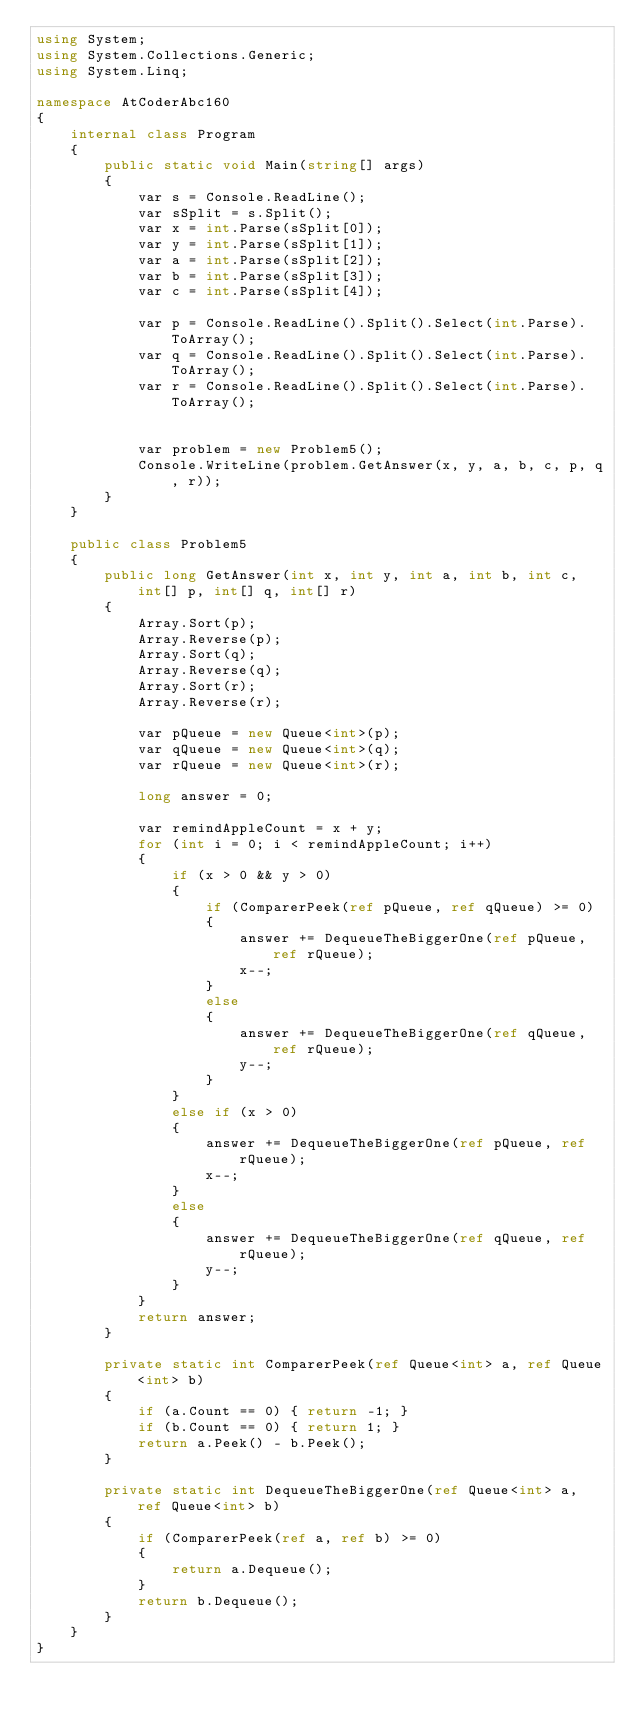<code> <loc_0><loc_0><loc_500><loc_500><_C#_>using System;
using System.Collections.Generic;
using System.Linq;

namespace AtCoderAbc160
{
    internal class Program
    {
        public static void Main(string[] args)
        {
            var s = Console.ReadLine();
            var sSplit = s.Split();
            var x = int.Parse(sSplit[0]);
            var y = int.Parse(sSplit[1]);
            var a = int.Parse(sSplit[2]);
            var b = int.Parse(sSplit[3]);
            var c = int.Parse(sSplit[4]);

            var p = Console.ReadLine().Split().Select(int.Parse).ToArray();
            var q = Console.ReadLine().Split().Select(int.Parse).ToArray();
            var r = Console.ReadLine().Split().Select(int.Parse).ToArray();


            var problem = new Problem5();
            Console.WriteLine(problem.GetAnswer(x, y, a, b, c, p, q, r));
        }
    }

    public class Problem5
    {
        public long GetAnswer(int x, int y, int a, int b, int c, int[] p, int[] q, int[] r)
        {
            Array.Sort(p);
            Array.Reverse(p);
            Array.Sort(q);
            Array.Reverse(q);
            Array.Sort(r);
            Array.Reverse(r);

            var pQueue = new Queue<int>(p);
            var qQueue = new Queue<int>(q);
            var rQueue = new Queue<int>(r);

            long answer = 0;

            var remindAppleCount = x + y;
            for (int i = 0; i < remindAppleCount; i++)
            {
                if (x > 0 && y > 0)
                {
                    if (ComparerPeek(ref pQueue, ref qQueue) >= 0)
                    {
                        answer += DequeueTheBiggerOne(ref pQueue, ref rQueue);
                        x--;
                    }
                    else
                    {
                        answer += DequeueTheBiggerOne(ref qQueue, ref rQueue);
                        y--;
                    }
                }
                else if (x > 0)
                {
                    answer += DequeueTheBiggerOne(ref pQueue, ref rQueue);
                    x--;
                }
                else
                {
                    answer += DequeueTheBiggerOne(ref qQueue, ref rQueue);
                    y--;
                }
            }
            return answer;
        }

        private static int ComparerPeek(ref Queue<int> a, ref Queue<int> b)
        {
            if (a.Count == 0) { return -1; }
            if (b.Count == 0) { return 1; }
            return a.Peek() - b.Peek();
        }

        private static int DequeueTheBiggerOne(ref Queue<int> a, ref Queue<int> b)
        {
            if (ComparerPeek(ref a, ref b) >= 0)
            {
                return a.Dequeue();
            }
            return b.Dequeue();
        }
    }
}</code> 